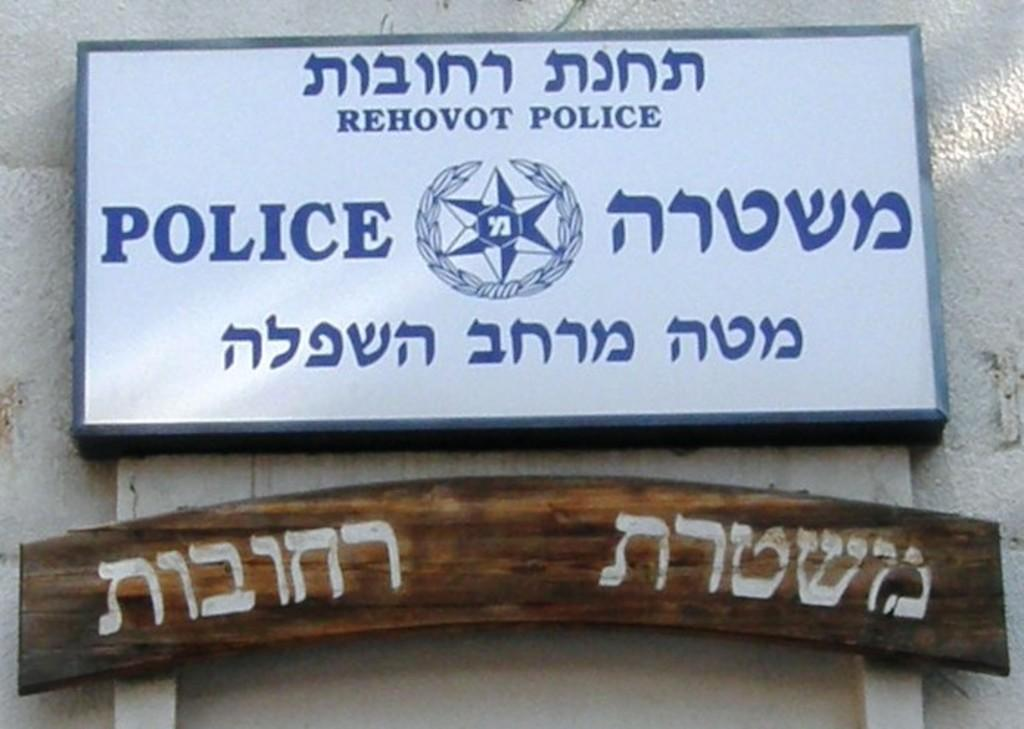<image>
Provide a brief description of the given image. Rehovot Police Station has a sign in English and Arabic 